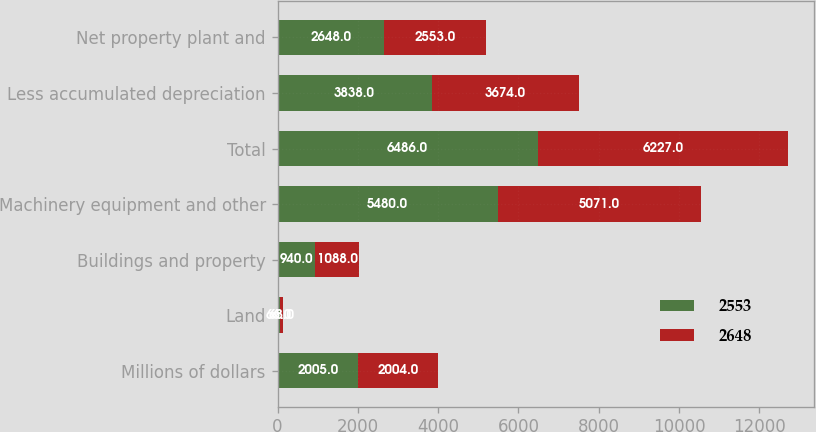Convert chart to OTSL. <chart><loc_0><loc_0><loc_500><loc_500><stacked_bar_chart><ecel><fcel>Millions of dollars<fcel>Land<fcel>Buildings and property<fcel>Machinery equipment and other<fcel>Total<fcel>Less accumulated depreciation<fcel>Net property plant and<nl><fcel>2553<fcel>2005<fcel>66<fcel>940<fcel>5480<fcel>6486<fcel>3838<fcel>2648<nl><fcel>2648<fcel>2004<fcel>68<fcel>1088<fcel>5071<fcel>6227<fcel>3674<fcel>2553<nl></chart> 